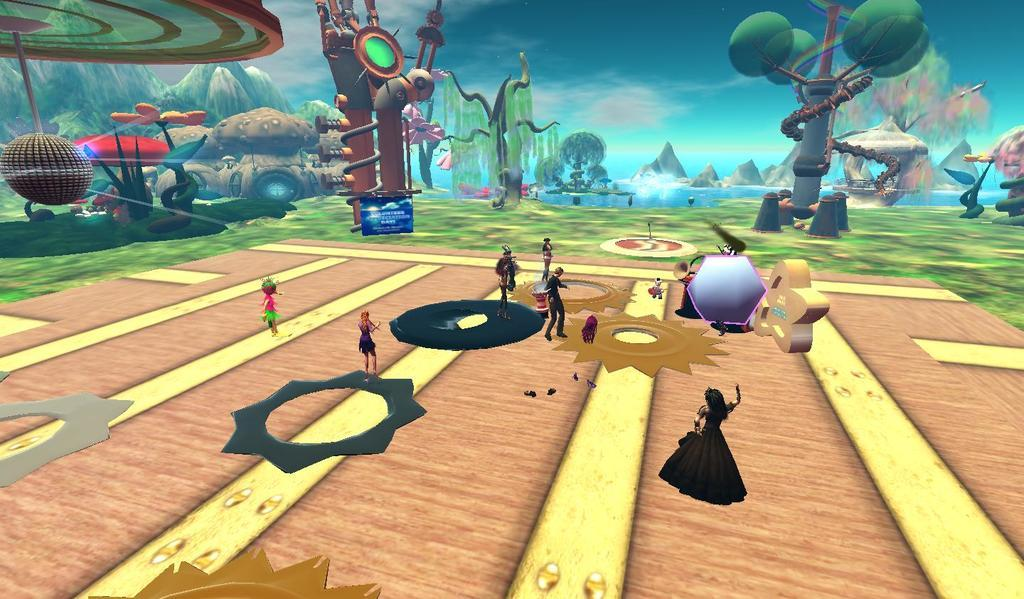Who or what can be seen in the image? There are people in the image. What type of natural environment is depicted in the image? There are trees, hills, water, sky, and ground visible in the image. What might be used for walking or hiking in the image? There is a path in the image. What other unspecified objects are present in the image? There are other unspecified objects in the image. What type of book can be seen in the image? There is no book present in the image. Can you hear a whistle in the image? There is no sound or indication of a whistle in the image. 